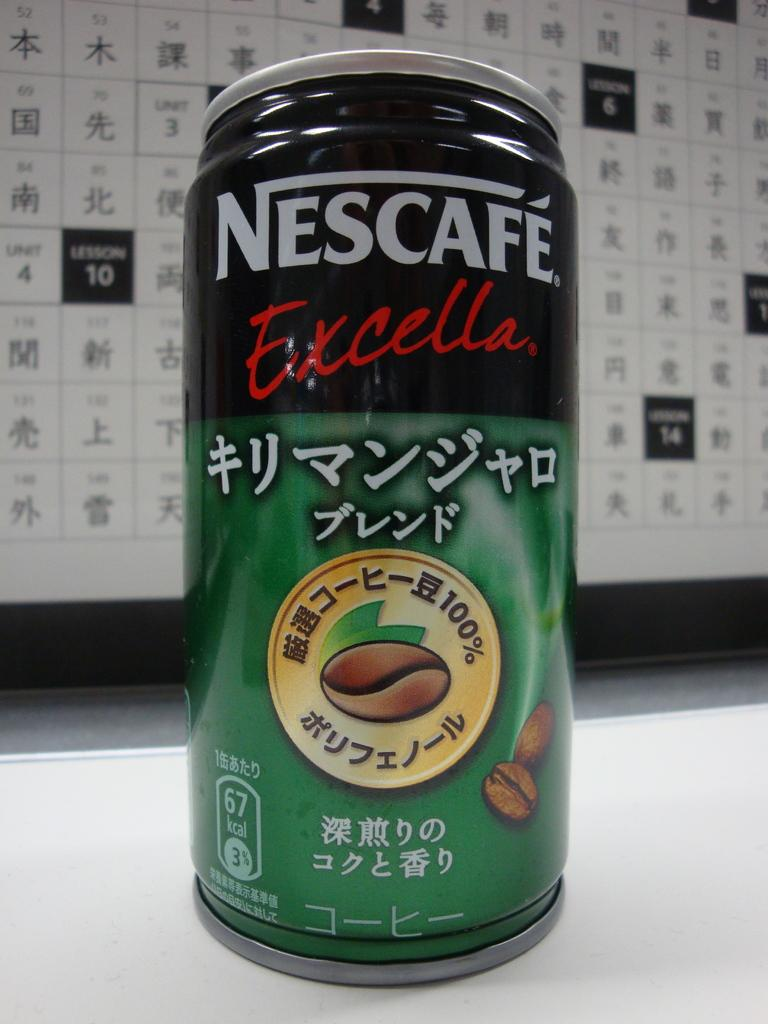<image>
Describe the image concisely. A can of Nescafe Excella also has writing in another language. 